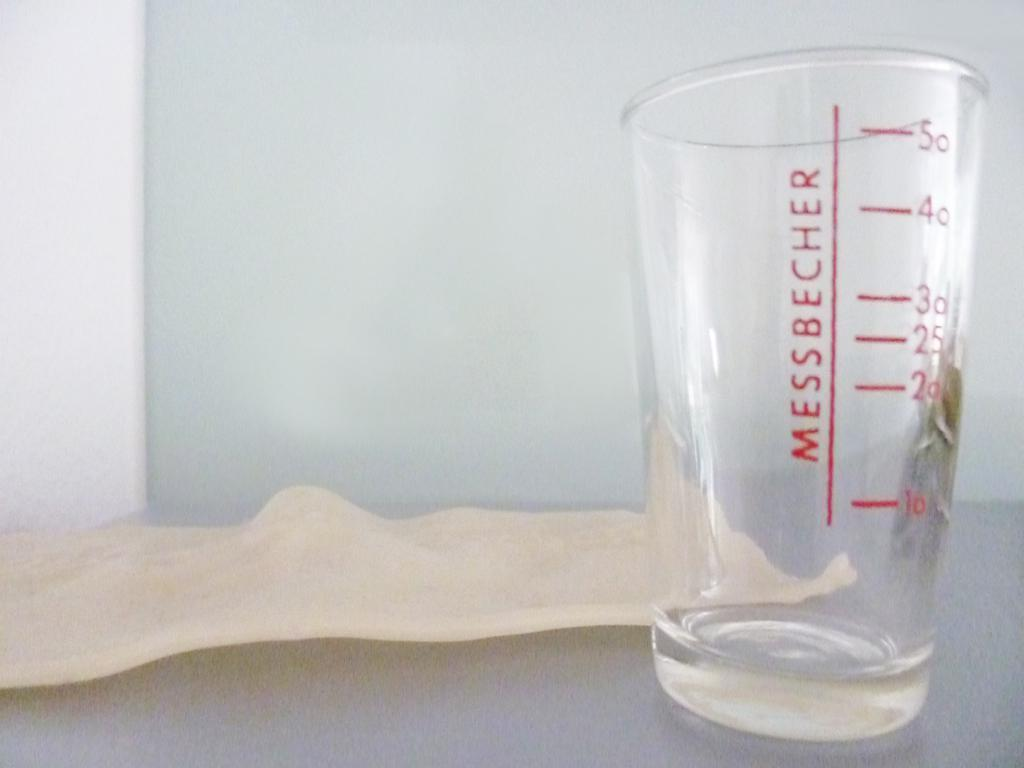<image>
Relay a brief, clear account of the picture shown. A Messbecher brand beaker offers measurements in red. 